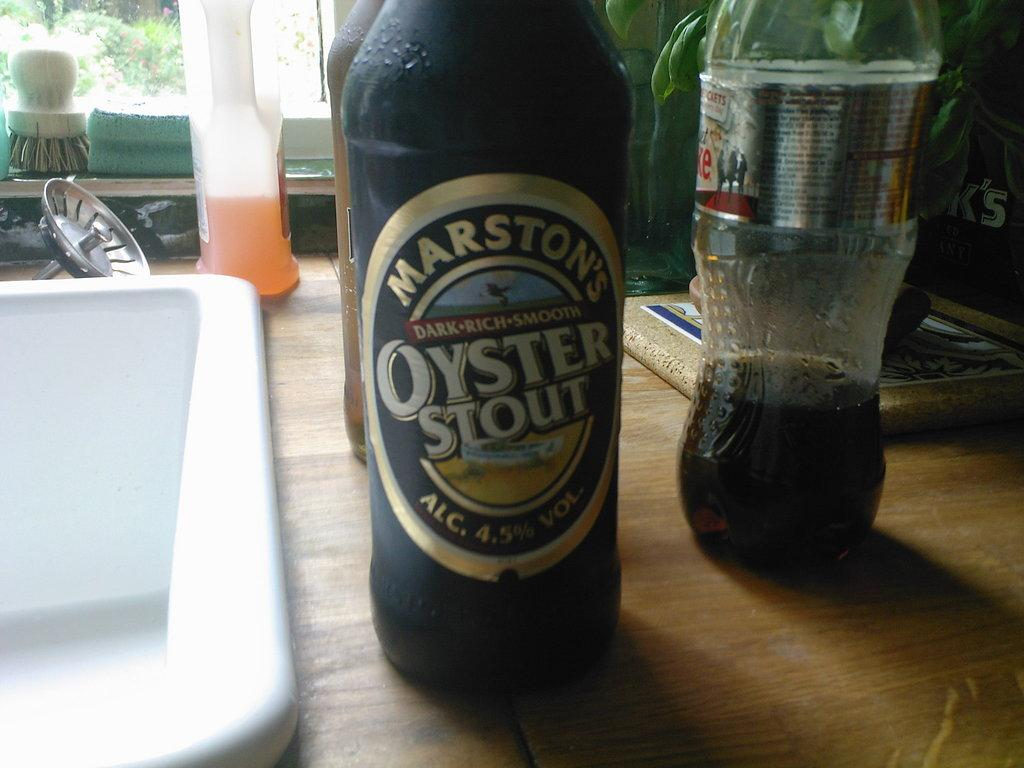<image>
Describe the image concisely. A bottle of Marston's Oyster Stout sits next to a kitchen sink. 